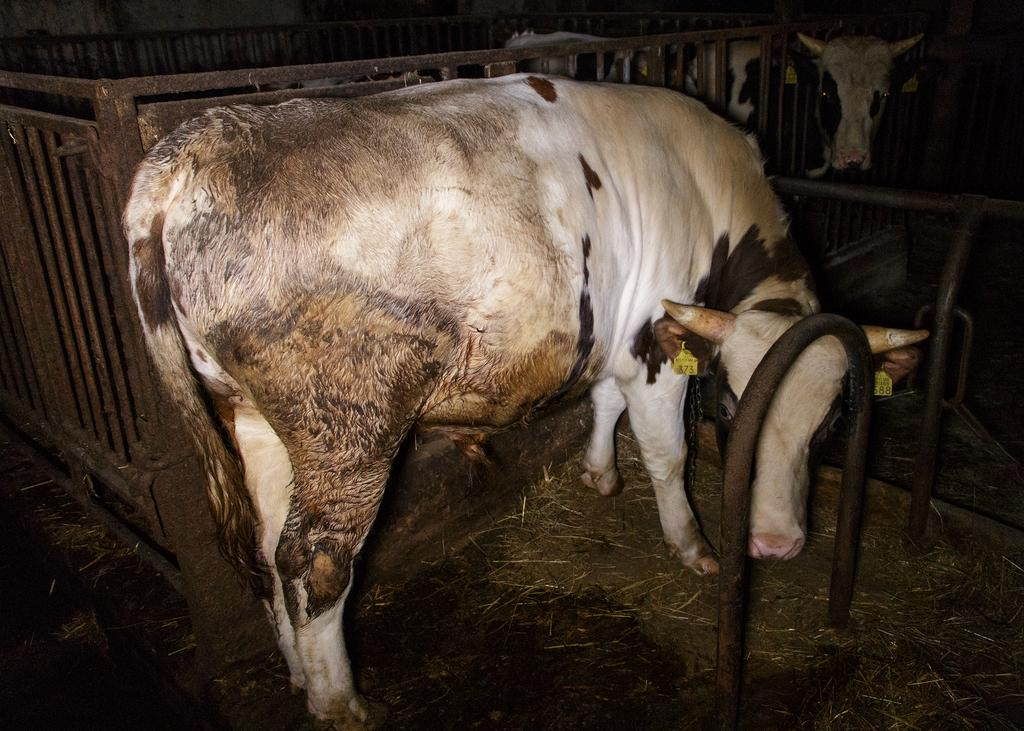What type of animal is in the image? There is a white cow in the image. Where is the cow located? The cow is standing in a cow shelter. What can be seen in the background of the image? There is a black color fencing grill in the background of the image. Can you see an owl sitting on the cow's back in the image? No, there is no owl present in the image. Is there a fire burning in the cow shelter in the image? No, there is no fire visible in the image. 